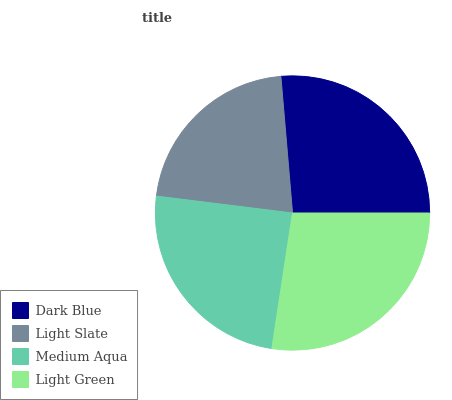Is Light Slate the minimum?
Answer yes or no. Yes. Is Light Green the maximum?
Answer yes or no. Yes. Is Medium Aqua the minimum?
Answer yes or no. No. Is Medium Aqua the maximum?
Answer yes or no. No. Is Medium Aqua greater than Light Slate?
Answer yes or no. Yes. Is Light Slate less than Medium Aqua?
Answer yes or no. Yes. Is Light Slate greater than Medium Aqua?
Answer yes or no. No. Is Medium Aqua less than Light Slate?
Answer yes or no. No. Is Dark Blue the high median?
Answer yes or no. Yes. Is Medium Aqua the low median?
Answer yes or no. Yes. Is Light Slate the high median?
Answer yes or no. No. Is Light Green the low median?
Answer yes or no. No. 